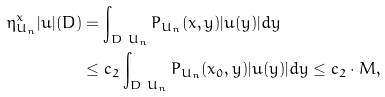Convert formula to latex. <formula><loc_0><loc_0><loc_500><loc_500>\eta ^ { x } _ { U _ { n } } | u | ( D ) & = \int _ { D \ U _ { n } } P _ { U _ { n } } ( x , y ) | u ( y ) | d y \\ & \leq c _ { 2 } \int _ { D \ U _ { n } } P _ { U _ { n } } ( x _ { 0 } , y ) | u ( y ) | d y \leq c _ { 2 } \cdot M ,</formula> 